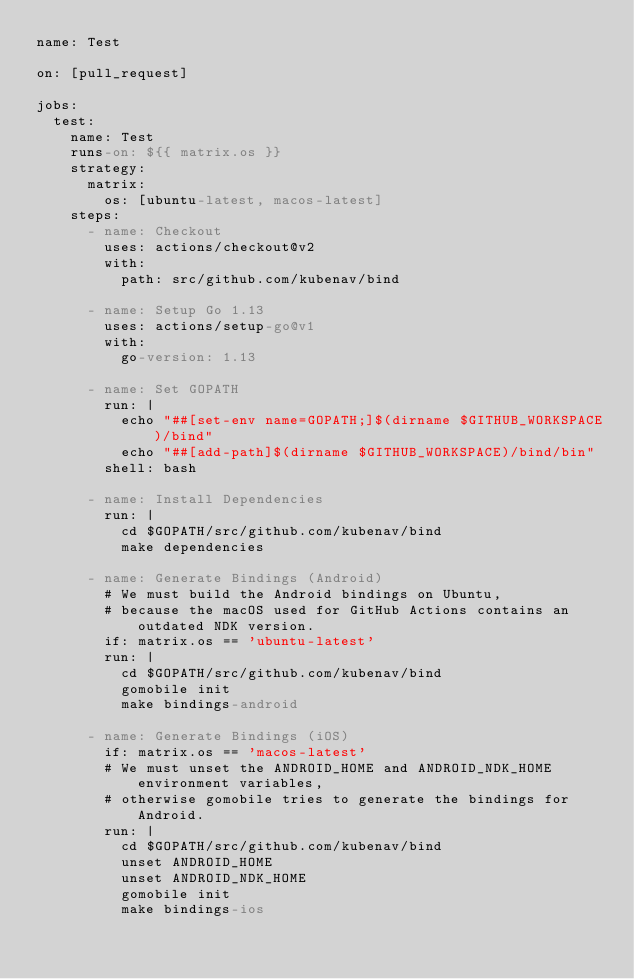<code> <loc_0><loc_0><loc_500><loc_500><_YAML_>name: Test

on: [pull_request]

jobs:
  test:
    name: Test
    runs-on: ${{ matrix.os }}
    strategy:
      matrix:
        os: [ubuntu-latest, macos-latest]
    steps:
      - name: Checkout
        uses: actions/checkout@v2
        with:
          path: src/github.com/kubenav/bind

      - name: Setup Go 1.13
        uses: actions/setup-go@v1
        with:
          go-version: 1.13

      - name: Set GOPATH
        run: |
          echo "##[set-env name=GOPATH;]$(dirname $GITHUB_WORKSPACE)/bind"
          echo "##[add-path]$(dirname $GITHUB_WORKSPACE)/bind/bin"
        shell: bash

      - name: Install Dependencies
        run: |
          cd $GOPATH/src/github.com/kubenav/bind
          make dependencies

      - name: Generate Bindings (Android)
        # We must build the Android bindings on Ubuntu,
        # because the macOS used for GitHub Actions contains an outdated NDK version.
        if: matrix.os == 'ubuntu-latest'
        run: |
          cd $GOPATH/src/github.com/kubenav/bind
          gomobile init
          make bindings-android

      - name: Generate Bindings (iOS)
        if: matrix.os == 'macos-latest'
        # We must unset the ANDROID_HOME and ANDROID_NDK_HOME environment variables,
        # otherwise gomobile tries to generate the bindings for Android.
        run: |
          cd $GOPATH/src/github.com/kubenav/bind
          unset ANDROID_HOME
          unset ANDROID_NDK_HOME
          gomobile init
          make bindings-ios
</code> 